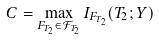Convert formula to latex. <formula><loc_0><loc_0><loc_500><loc_500>C = \max _ { F _ { T _ { 2 } } \in \mathcal { F } _ { T _ { 2 } } } I _ { F _ { T _ { 2 } } } ( T _ { 2 } ; Y )</formula> 